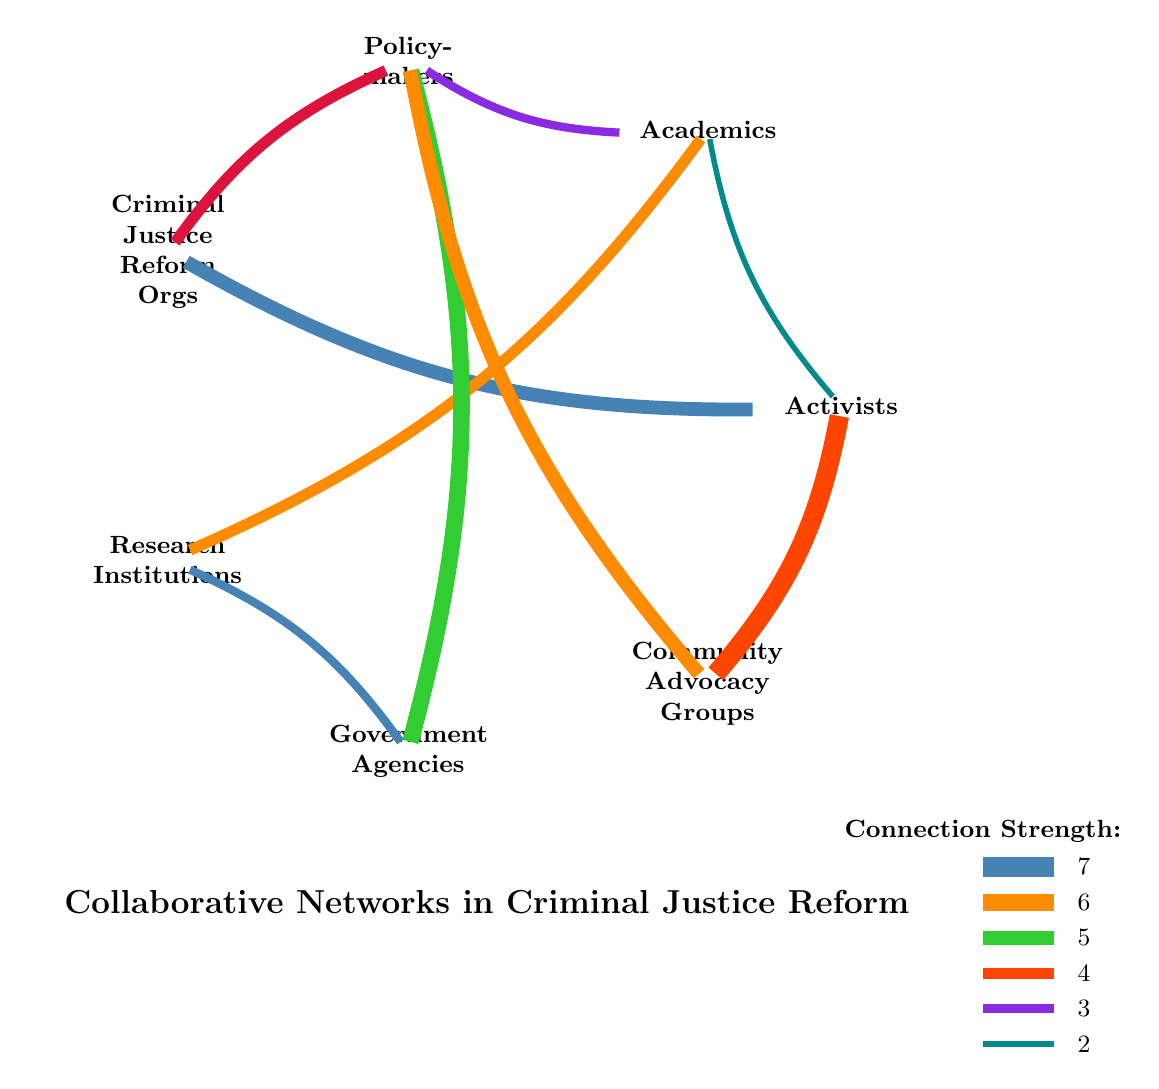What is the link strength between Activists and Criminal Justice Reform Organizations? The diagram indicates a link from Activists to Criminal Justice Reform Organizations with a value of 5, represented by the line connecting these two nodes.
Answer: 5 What is the total number of nodes present in the diagram? Counting the nodes listed in the diagram, we find seven distinct nodes: Activists, Academics, Policymakers, Criminal Justice Reform Organizations, Research Institutions, Government Agencies, and Community Advocacy Groups.
Answer: 7 Which node has the strongest connection to Community Advocacy Groups? The strongest link emanating from Community Advocacy Groups is to Policymakers, as denoted by the line thickness of 5, indicating the value of their connection.
Answer: Policymakers What is the relationship between Academics and Policymakers? The relationship is quantified by a link with a value of 3, showing a moderate level of collaboration indicated by the corresponding line in the diagram.
Answer: 3 Which two nodes have a direct connection of strength 4? The diagram shows two direct connections with the same strength of 4: one between Criminal Justice Reform Organizations and Policymakers, and another between Academics and Research Institutions.
Answer: Criminal Justice Reform Organizations and Policymakers; Academics and Research Institutions How many connections involve Activists? By inspecting the diagram, we can count the specific links stemming from Activists: to Criminal Justice Reform Organizations (5), to Community Advocacy Groups (7), to Academics (2), totaling 4 connections.
Answer: 4 What color represents the link strength of 6? The line connecting Policymakers to Government Agencies has the color associated with strength 6, indicated by the line's thickness and chosen color in the diagram.
Answer: Color3 Which type of organization connects directly to both Academics and Policymakers? The only type of organization directly linking both Academics and Policymakers is the Criminal Justice Reform Organizations, as shown by the respective connections in the diagram.
Answer: Criminal Justice Reform Organizations 